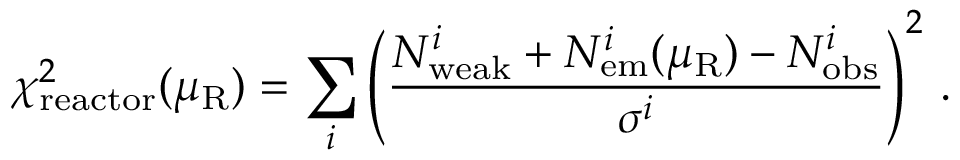Convert formula to latex. <formula><loc_0><loc_0><loc_500><loc_500>\chi _ { r e a c t o r } ^ { 2 } ( \mu _ { R } ) = \sum _ { i } \left ( \frac { N _ { w e a k } ^ { i } + N _ { e m } ^ { i } ( \mu _ { R } ) - N _ { o b s } ^ { i } } { \sigma ^ { i } } \right ) ^ { 2 } \, .</formula> 